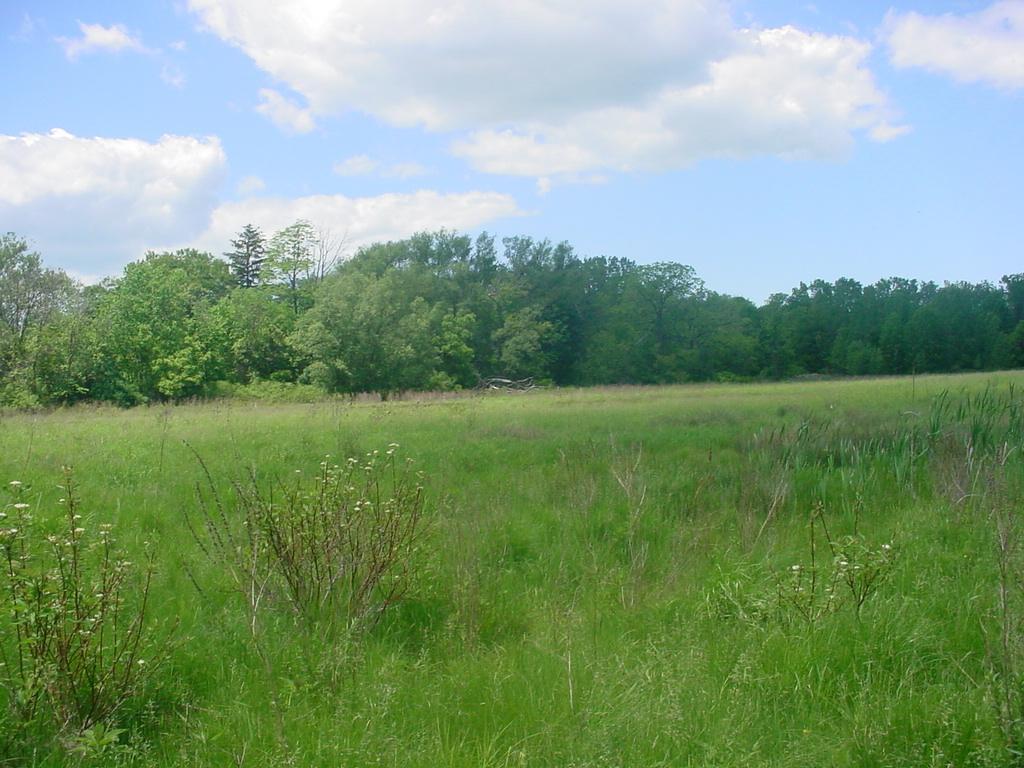Please provide a concise description of this image. In the foreground of the image we can see group of plants and grass. In the background, we can see a group of trees and the cloudy sky. 